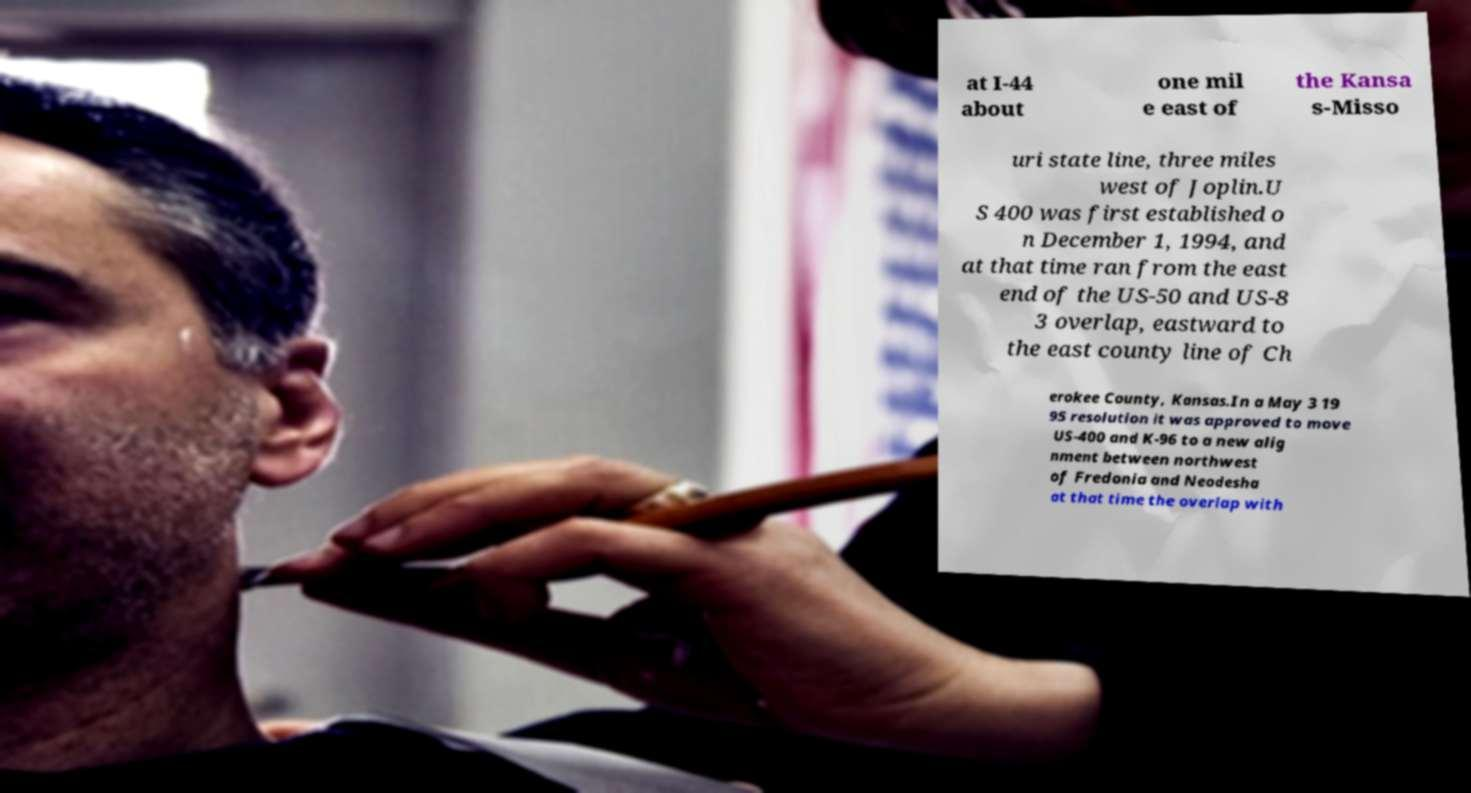What messages or text are displayed in this image? I need them in a readable, typed format. at I-44 about one mil e east of the Kansa s-Misso uri state line, three miles west of Joplin.U S 400 was first established o n December 1, 1994, and at that time ran from the east end of the US-50 and US-8 3 overlap, eastward to the east county line of Ch erokee County, Kansas.In a May 3 19 95 resolution it was approved to move US-400 and K-96 to a new alig nment between northwest of Fredonia and Neodesha at that time the overlap with 